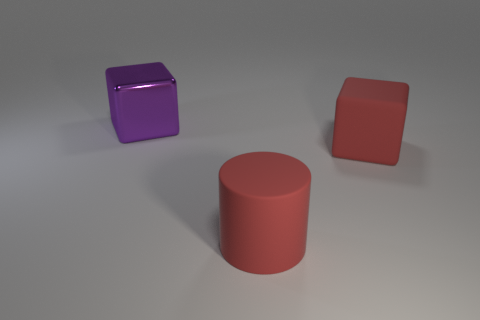There is a cube that is on the right side of the big purple metallic block; is its size the same as the block that is to the left of the large red matte cylinder?
Keep it short and to the point. Yes. Is there a large red cube that has the same material as the big cylinder?
Offer a very short reply. Yes. What is the size of the thing that is the same color as the large matte cylinder?
Provide a succinct answer. Large. There is a large red rubber object in front of the red object that is behind the big rubber cylinder; is there a big red matte thing right of it?
Provide a short and direct response. Yes. There is a big purple shiny block; are there any rubber things in front of it?
Provide a succinct answer. Yes. How many red matte cubes are behind the big cube that is on the right side of the purple block?
Your response must be concise. 0. Is there a matte object of the same color as the big matte cube?
Give a very brief answer. Yes. There is a red cube that is the same material as the large cylinder; what is its size?
Make the answer very short. Large. Does the big red cylinder have the same material as the red cube?
Your response must be concise. Yes. The object that is to the right of the large rubber object that is in front of the cube right of the metal thing is what color?
Offer a very short reply. Red. 